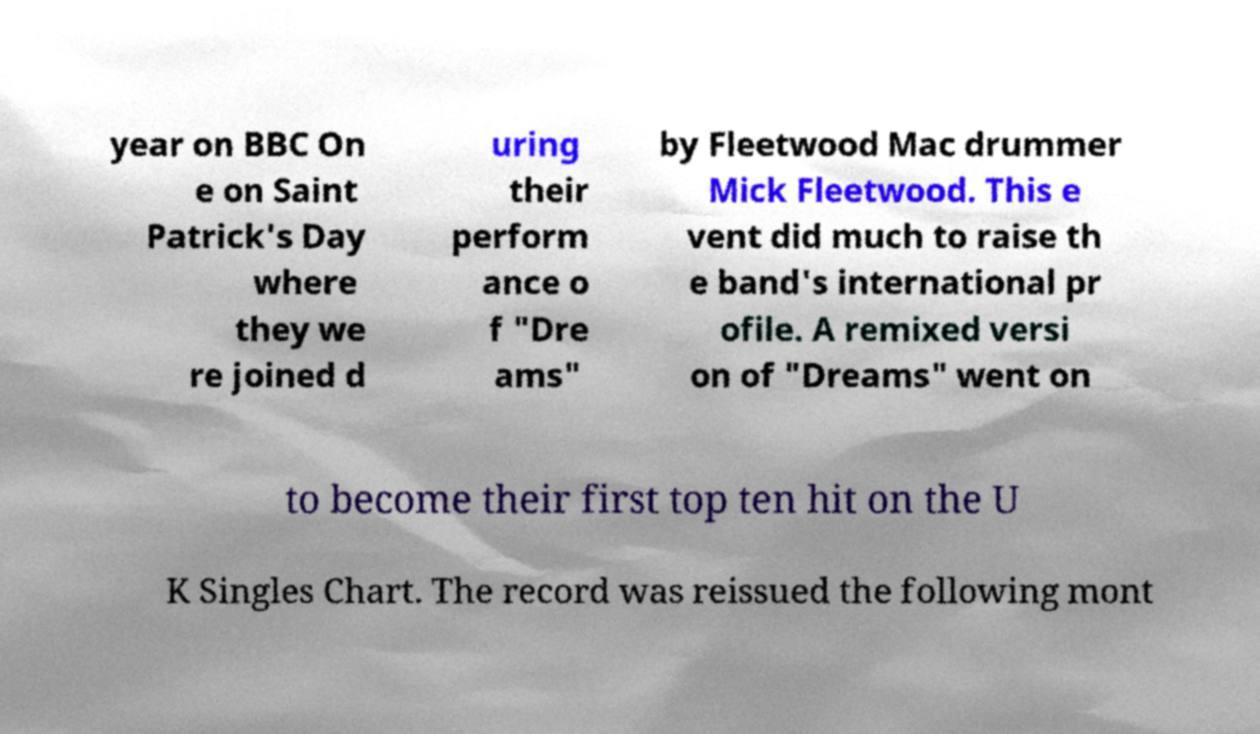Could you assist in decoding the text presented in this image and type it out clearly? year on BBC On e on Saint Patrick's Day where they we re joined d uring their perform ance o f "Dre ams" by Fleetwood Mac drummer Mick Fleetwood. This e vent did much to raise th e band's international pr ofile. A remixed versi on of "Dreams" went on to become their first top ten hit on the U K Singles Chart. The record was reissued the following mont 